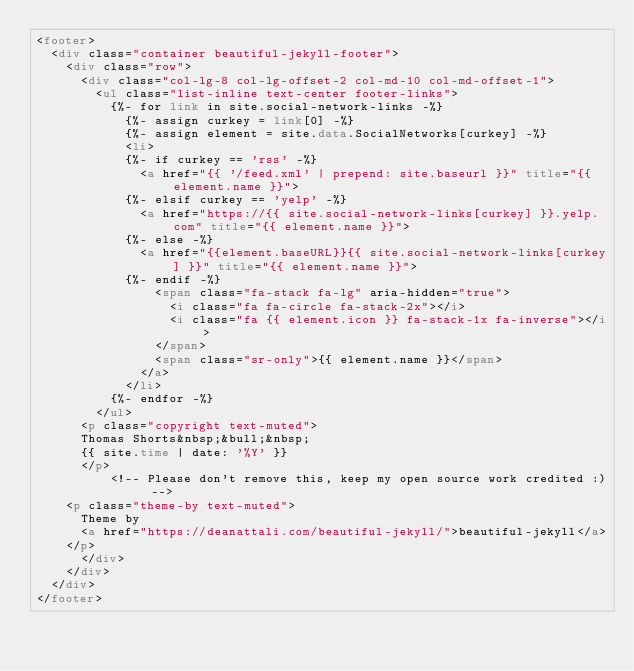Convert code to text. <code><loc_0><loc_0><loc_500><loc_500><_HTML_><footer>
  <div class="container beautiful-jekyll-footer">
    <div class="row">
      <div class="col-lg-8 col-lg-offset-2 col-md-10 col-md-offset-1">
        <ul class="list-inline text-center footer-links">
          {%- for link in site.social-network-links -%}
            {%- assign curkey = link[0] -%}
            {%- assign element = site.data.SocialNetworks[curkey] -%}
            <li>
            {%- if curkey == 'rss' -%}
              <a href="{{ '/feed.xml' | prepend: site.baseurl }}" title="{{ element.name }}">
            {%- elsif curkey == 'yelp' -%}
              <a href="https://{{ site.social-network-links[curkey] }}.yelp.com" title="{{ element.name }}">
            {%- else -%}
              <a href="{{element.baseURL}}{{ site.social-network-links[curkey] }}" title="{{ element.name }}">
            {%- endif -%}
                <span class="fa-stack fa-lg" aria-hidden="true">
                  <i class="fa fa-circle fa-stack-2x"></i>
                  <i class="fa {{ element.icon }} fa-stack-1x fa-inverse"></i>
                </span>
                <span class="sr-only">{{ element.name }}</span>
              </a>
            </li>
          {%- endfor -%}
        </ul>
      <p class="copyright text-muted">  
      Thomas Shorts&nbsp;&bull;&nbsp;
      {{ site.time | date: '%Y' }}
      </p>
          <!-- Please don't remove this, keep my open source work credited :) -->
    <p class="theme-by text-muted">
      Theme by
      <a href="https://deanattali.com/beautiful-jekyll/">beautiful-jekyll</a>
    </p>
      </div>
    </div>
  </div>
</footer>
</code> 